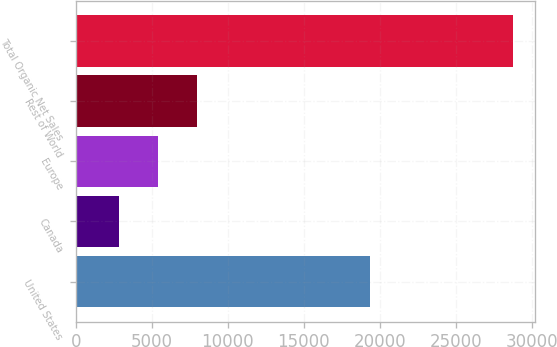Convert chart to OTSL. <chart><loc_0><loc_0><loc_500><loc_500><bar_chart><fcel>United States<fcel>Canada<fcel>Europe<fcel>Rest of World<fcel>Total Organic Net Sales<nl><fcel>19346<fcel>2811<fcel>5404<fcel>7997<fcel>28741<nl></chart> 